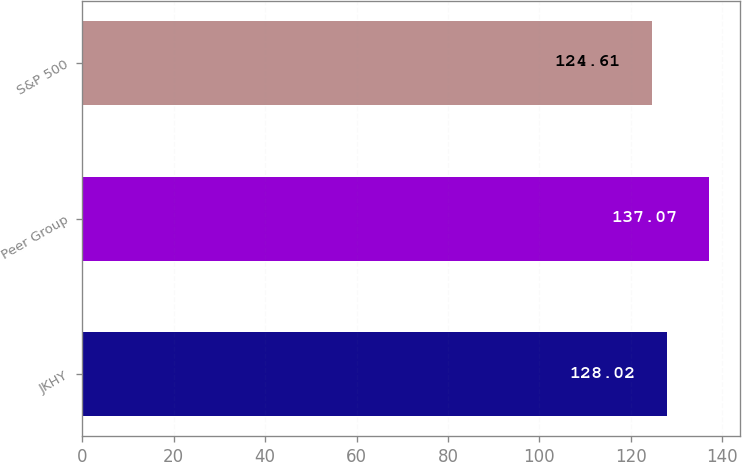Convert chart. <chart><loc_0><loc_0><loc_500><loc_500><bar_chart><fcel>JKHY<fcel>Peer Group<fcel>S&P 500<nl><fcel>128.02<fcel>137.07<fcel>124.61<nl></chart> 